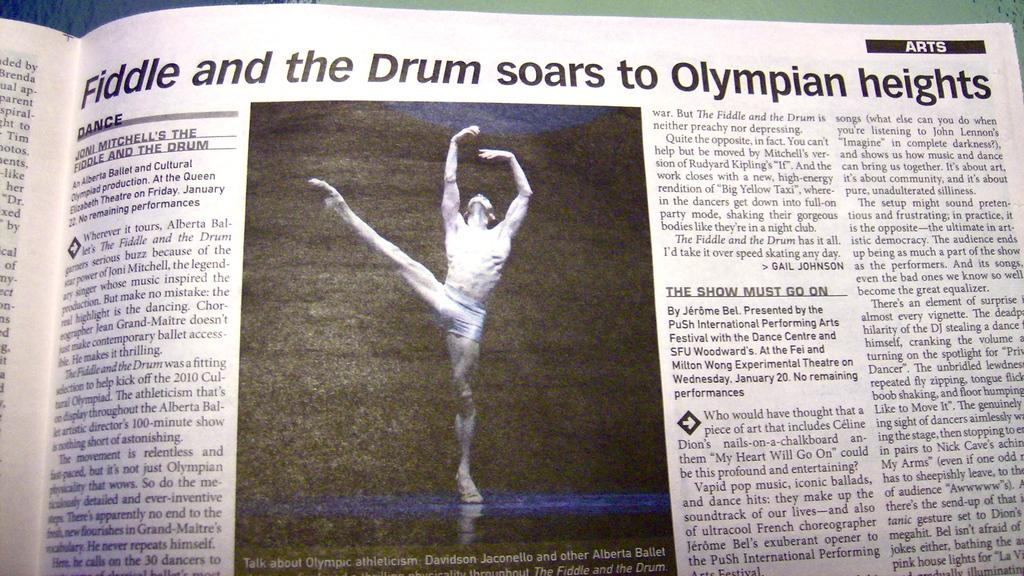<image>
Summarize the visual content of the image. A newspaper article with the headline "Fiddle and the drum soars to olympian heights" with a picture of a mane ballet dancing. 